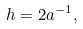Convert formula to latex. <formula><loc_0><loc_0><loc_500><loc_500>h = 2 a ^ { - 1 } ,</formula> 